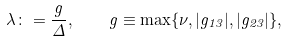<formula> <loc_0><loc_0><loc_500><loc_500>\lambda \colon = \frac { g } { \Delta } , \quad g \equiv \max \{ \nu , | g _ { 1 3 } | , | g _ { 2 3 } | \} ,</formula> 